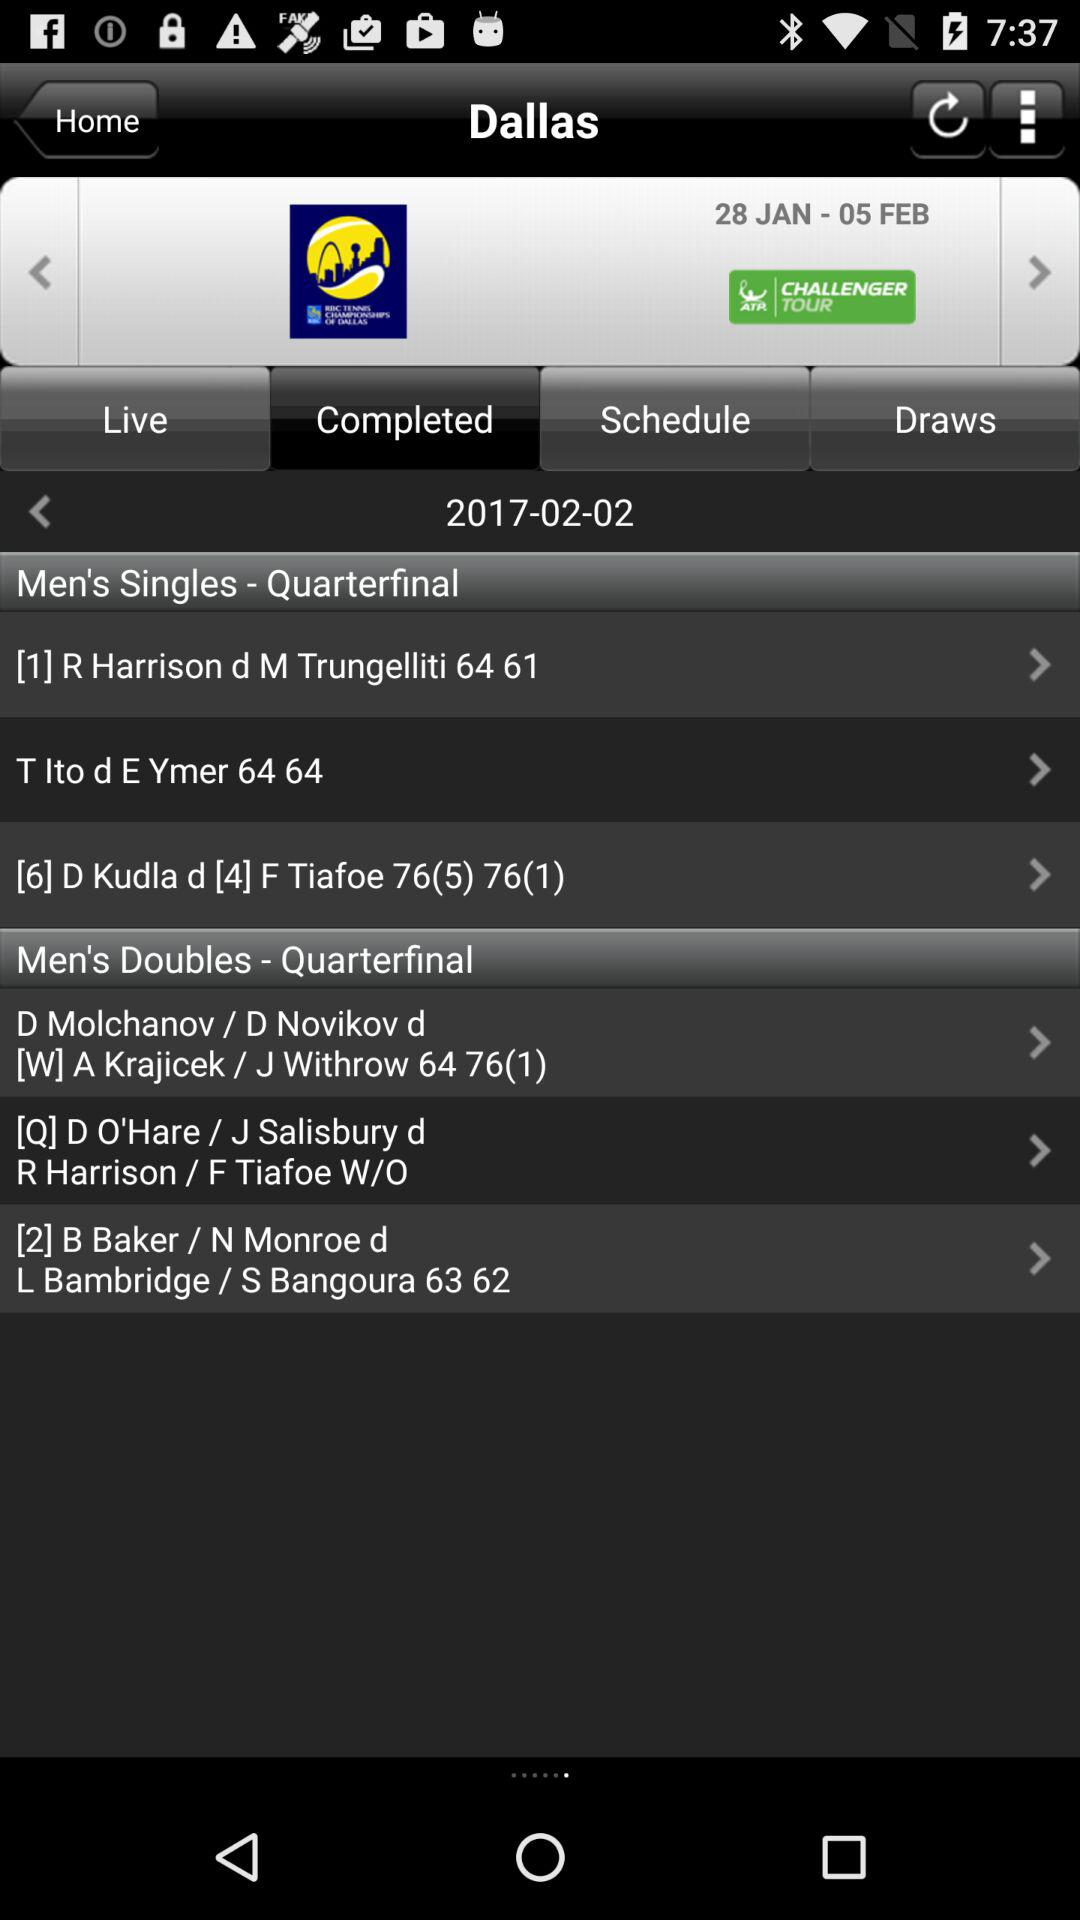When is the next game?
When the provided information is insufficient, respond with <no answer>. <no answer> 